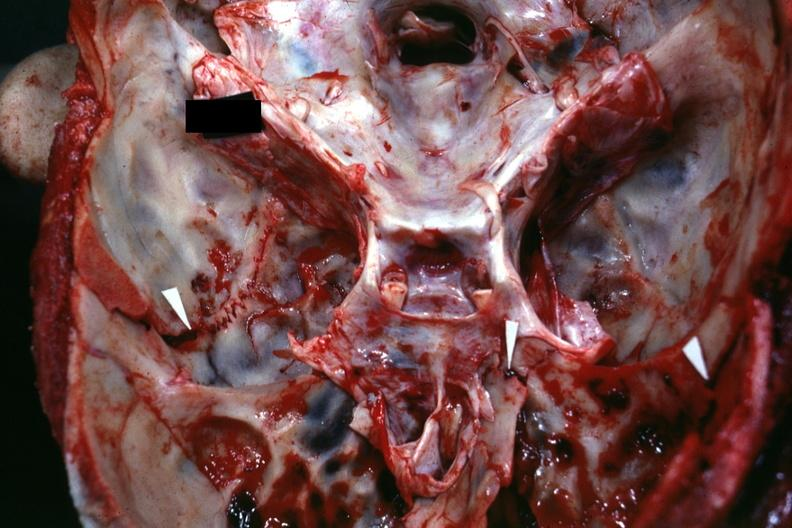s basilar skull fracture present?
Answer the question using a single word or phrase. Yes 